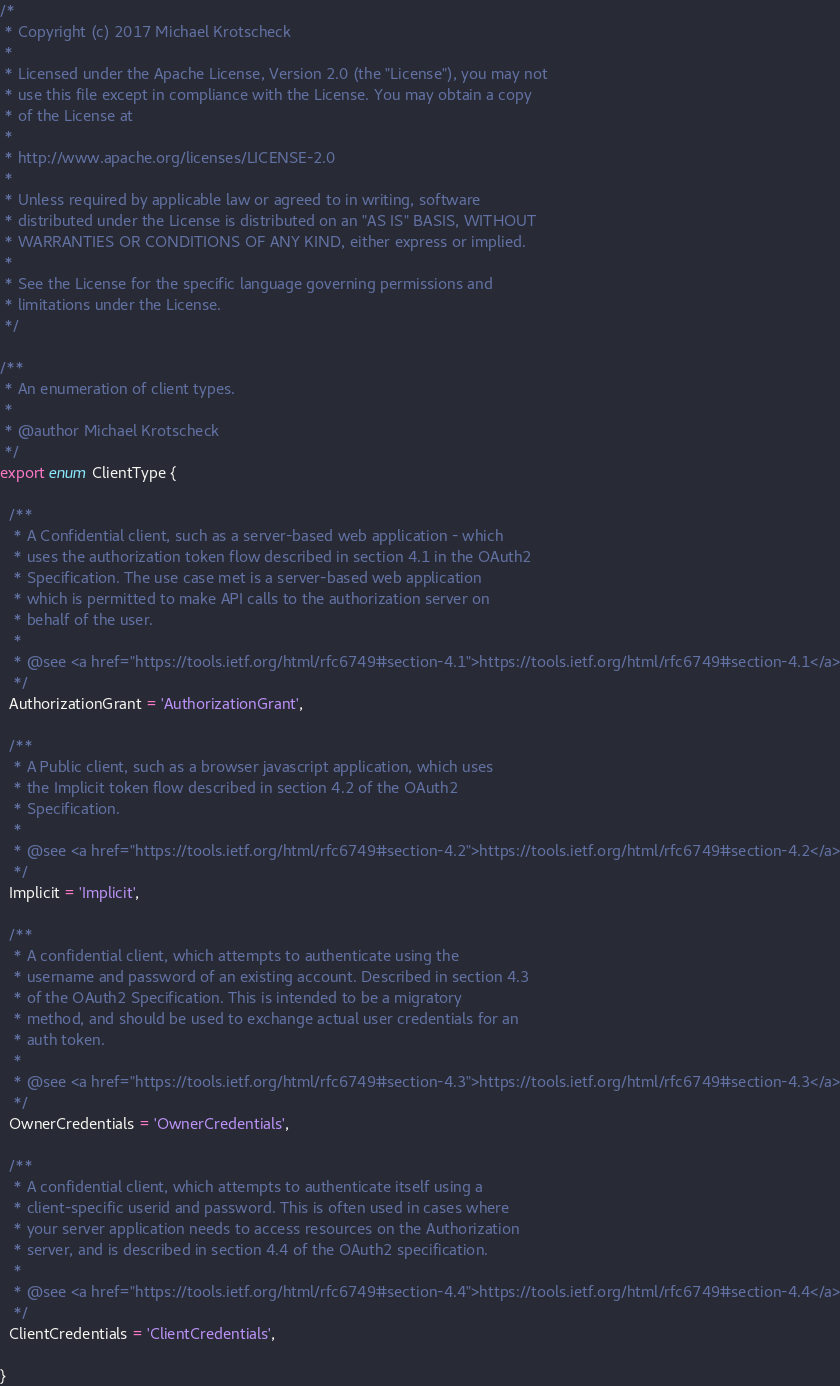<code> <loc_0><loc_0><loc_500><loc_500><_TypeScript_>/*
 * Copyright (c) 2017 Michael Krotscheck
 *
 * Licensed under the Apache License, Version 2.0 (the "License"), you may not
 * use this file except in compliance with the License. You may obtain a copy
 * of the License at
 *
 * http://www.apache.org/licenses/LICENSE-2.0
 *
 * Unless required by applicable law or agreed to in writing, software
 * distributed under the License is distributed on an "AS IS" BASIS, WITHOUT
 * WARRANTIES OR CONDITIONS OF ANY KIND, either express or implied.
 *
 * See the License for the specific language governing permissions and
 * limitations under the License.
 */

/**
 * An enumeration of client types.
 *
 * @author Michael Krotscheck
 */
export enum ClientType {

  /**
   * A Confidential client, such as a server-based web application - which
   * uses the authorization token flow described in section 4.1 in the OAuth2
   * Specification. The use case met is a server-based web application
   * which is permitted to make API calls to the authorization server on
   * behalf of the user.
   *
   * @see <a href="https://tools.ietf.org/html/rfc6749#section-4.1">https://tools.ietf.org/html/rfc6749#section-4.1</a>
   */
  AuthorizationGrant = 'AuthorizationGrant',

  /**
   * A Public client, such as a browser javascript application, which uses
   * the Implicit token flow described in section 4.2 of the OAuth2
   * Specification.
   *
   * @see <a href="https://tools.ietf.org/html/rfc6749#section-4.2">https://tools.ietf.org/html/rfc6749#section-4.2</a>
   */
  Implicit = 'Implicit',

  /**
   * A confidential client, which attempts to authenticate using the
   * username and password of an existing account. Described in section 4.3
   * of the OAuth2 Specification. This is intended to be a migratory
   * method, and should be used to exchange actual user credentials for an
   * auth token.
   *
   * @see <a href="https://tools.ietf.org/html/rfc6749#section-4.3">https://tools.ietf.org/html/rfc6749#section-4.3</a>
   */
  OwnerCredentials = 'OwnerCredentials',

  /**
   * A confidential client, which attempts to authenticate itself using a
   * client-specific userid and password. This is often used in cases where
   * your server application needs to access resources on the Authorization
   * server, and is described in section 4.4 of the OAuth2 specification.
   *
   * @see <a href="https://tools.ietf.org/html/rfc6749#section-4.4">https://tools.ietf.org/html/rfc6749#section-4.4</a>
   */
  ClientCredentials = 'ClientCredentials',

}
</code> 